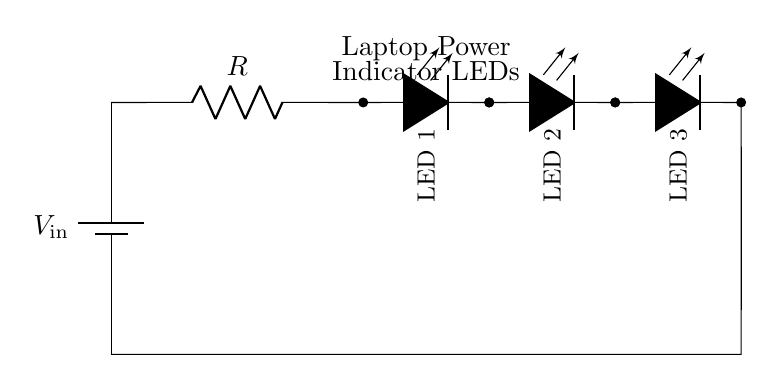What is the type of power source used in the circuit? The power source used is a battery, indicated by the symbol and label at the left side of the diagram.
Answer: Battery How many LEDs are connected in the circuit? The circuit includes three LEDs, as shown by three successive LED symbols connected in series.
Answer: Three What is the function of the resistor in this circuit? The resistor limits the current flowing through the LEDs, preventing them from drawing too much current which could lead to damage.
Answer: Current limiting What would happen if the resistor value is too high? If the resistor value is too high, insufficient current will flow through the circuit, causing the LEDs to either dim or not light up at all.
Answer: LEDs may not light What is the total voltage supplied to the LED array? The total voltage supplied corresponds to the voltage of the battery, labeled as V in the diagram; it is not specified, but all LEDs receive this voltage.
Answer: V in What is the nature of the connections between the components in this circuit? The components are connected in series, indicated by the single path of current flow from the battery through the resistor to the LEDs.
Answer: Series What would occur if one LED in the array fails? If one LED fails, it will break the series circuit, causing all LEDs to turn off as there would be no current flow through the circuit.
Answer: All off 